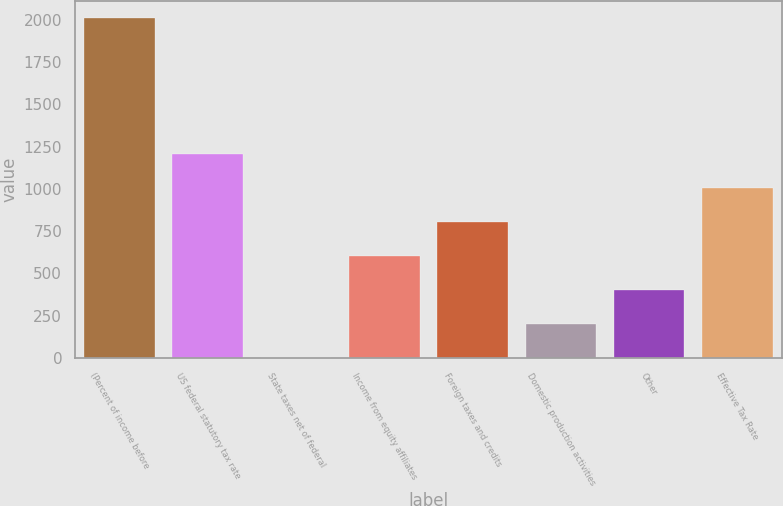<chart> <loc_0><loc_0><loc_500><loc_500><bar_chart><fcel>(Percent of income before<fcel>US federal statutory tax rate<fcel>State taxes net of federal<fcel>Income from equity affiliates<fcel>Foreign taxes and credits<fcel>Domestic production activities<fcel>Other<fcel>Effective Tax Rate<nl><fcel>2013<fcel>1208<fcel>0.5<fcel>604.25<fcel>805.5<fcel>201.75<fcel>403<fcel>1006.75<nl></chart> 